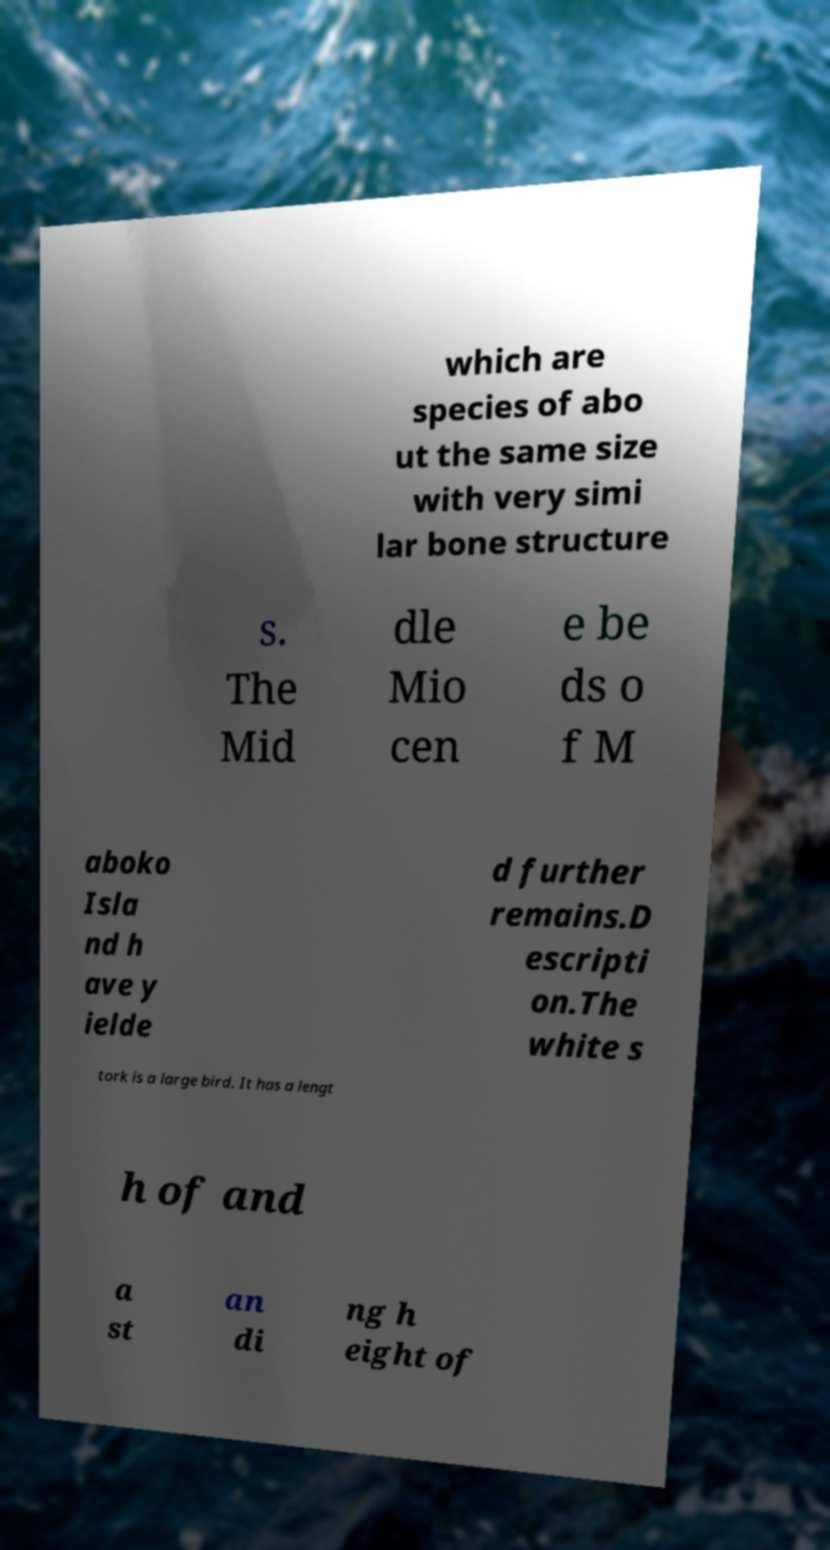I need the written content from this picture converted into text. Can you do that? which are species of abo ut the same size with very simi lar bone structure s. The Mid dle Mio cen e be ds o f M aboko Isla nd h ave y ielde d further remains.D escripti on.The white s tork is a large bird. It has a lengt h of and a st an di ng h eight of 